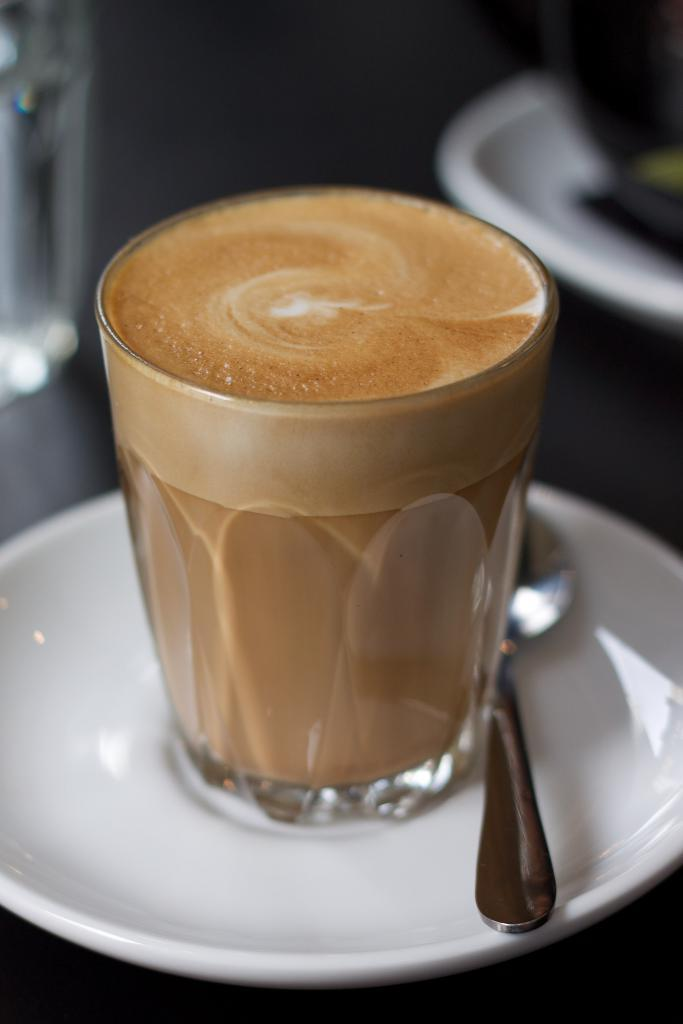What is located in the foreground of the image? There is a saucer cup and a spoon in the foreground of the image. What is inside the saucer cup? There is coffee in the saucer cup. Can you describe another object in the image? There is another saucer in the background of the image. What type of stitch is used to create the pattern on the saucer cup? The saucer cup does not have a pattern that requires stitching; it is a solid color or design. 